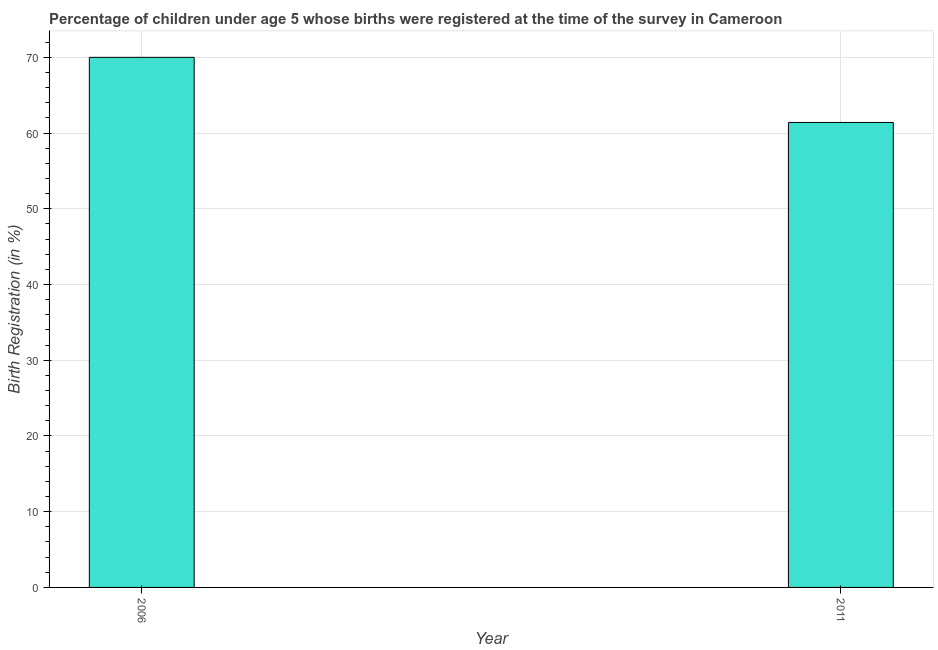Does the graph contain any zero values?
Offer a terse response. No. What is the title of the graph?
Make the answer very short. Percentage of children under age 5 whose births were registered at the time of the survey in Cameroon. What is the label or title of the Y-axis?
Give a very brief answer. Birth Registration (in %). What is the birth registration in 2011?
Offer a very short reply. 61.4. Across all years, what is the minimum birth registration?
Offer a very short reply. 61.4. What is the sum of the birth registration?
Provide a short and direct response. 131.4. What is the difference between the birth registration in 2006 and 2011?
Offer a very short reply. 8.6. What is the average birth registration per year?
Give a very brief answer. 65.7. What is the median birth registration?
Make the answer very short. 65.7. Do a majority of the years between 2011 and 2006 (inclusive) have birth registration greater than 56 %?
Offer a terse response. No. What is the ratio of the birth registration in 2006 to that in 2011?
Give a very brief answer. 1.14. Is the birth registration in 2006 less than that in 2011?
Provide a succinct answer. No. Are all the bars in the graph horizontal?
Provide a short and direct response. No. How many years are there in the graph?
Offer a very short reply. 2. Are the values on the major ticks of Y-axis written in scientific E-notation?
Your answer should be very brief. No. What is the Birth Registration (in %) of 2011?
Your response must be concise. 61.4. What is the difference between the Birth Registration (in %) in 2006 and 2011?
Offer a terse response. 8.6. What is the ratio of the Birth Registration (in %) in 2006 to that in 2011?
Make the answer very short. 1.14. 